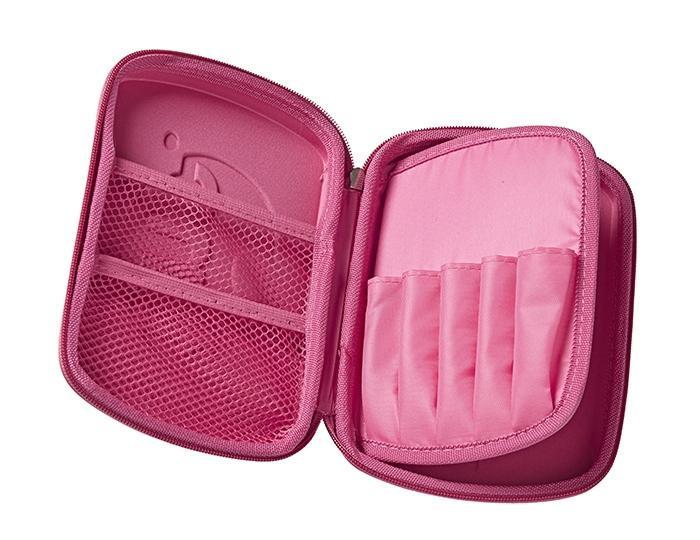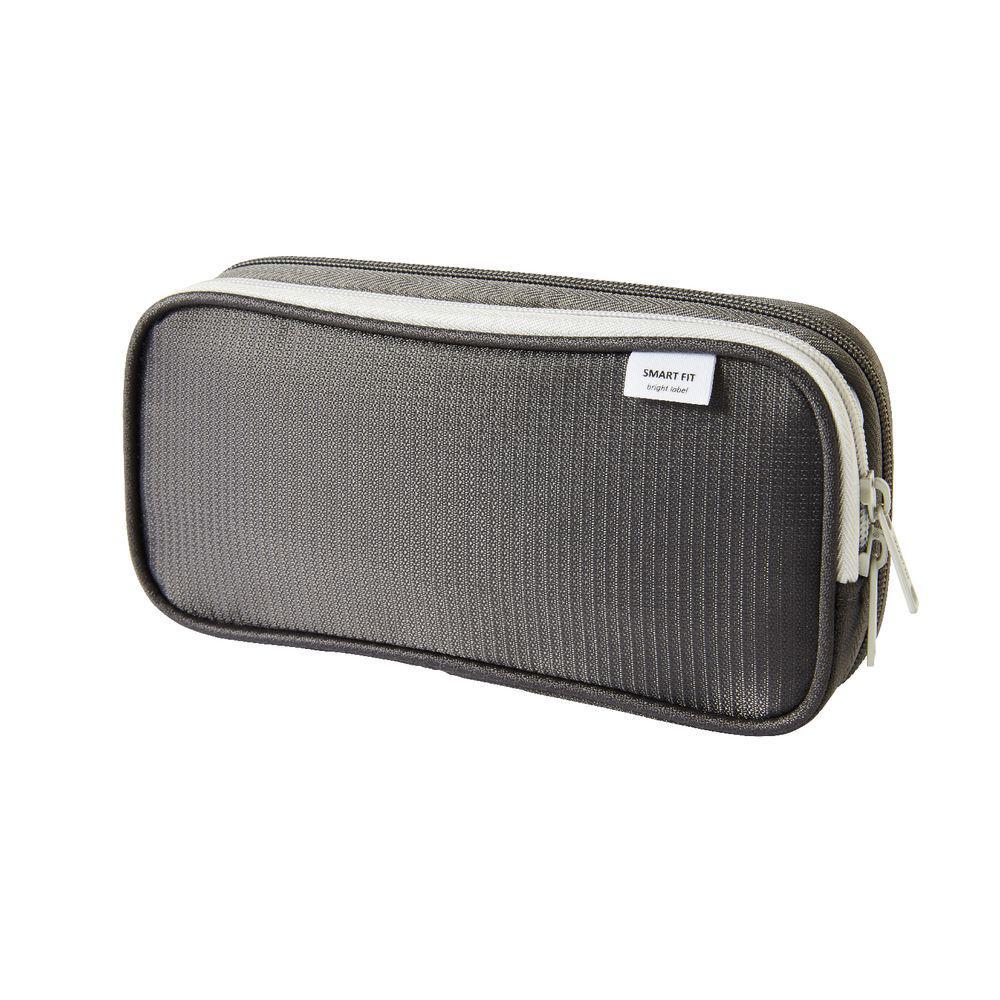The first image is the image on the left, the second image is the image on the right. Evaluate the accuracy of this statement regarding the images: "Exactly one bag is closed.". Is it true? Answer yes or no. Yes. The first image is the image on the left, the second image is the image on the right. Analyze the images presented: Is the assertion "Only pencil cases with zipper closures are shown, at least one case is hot pink, one case is closed, and at least one case is open." valid? Answer yes or no. Yes. 